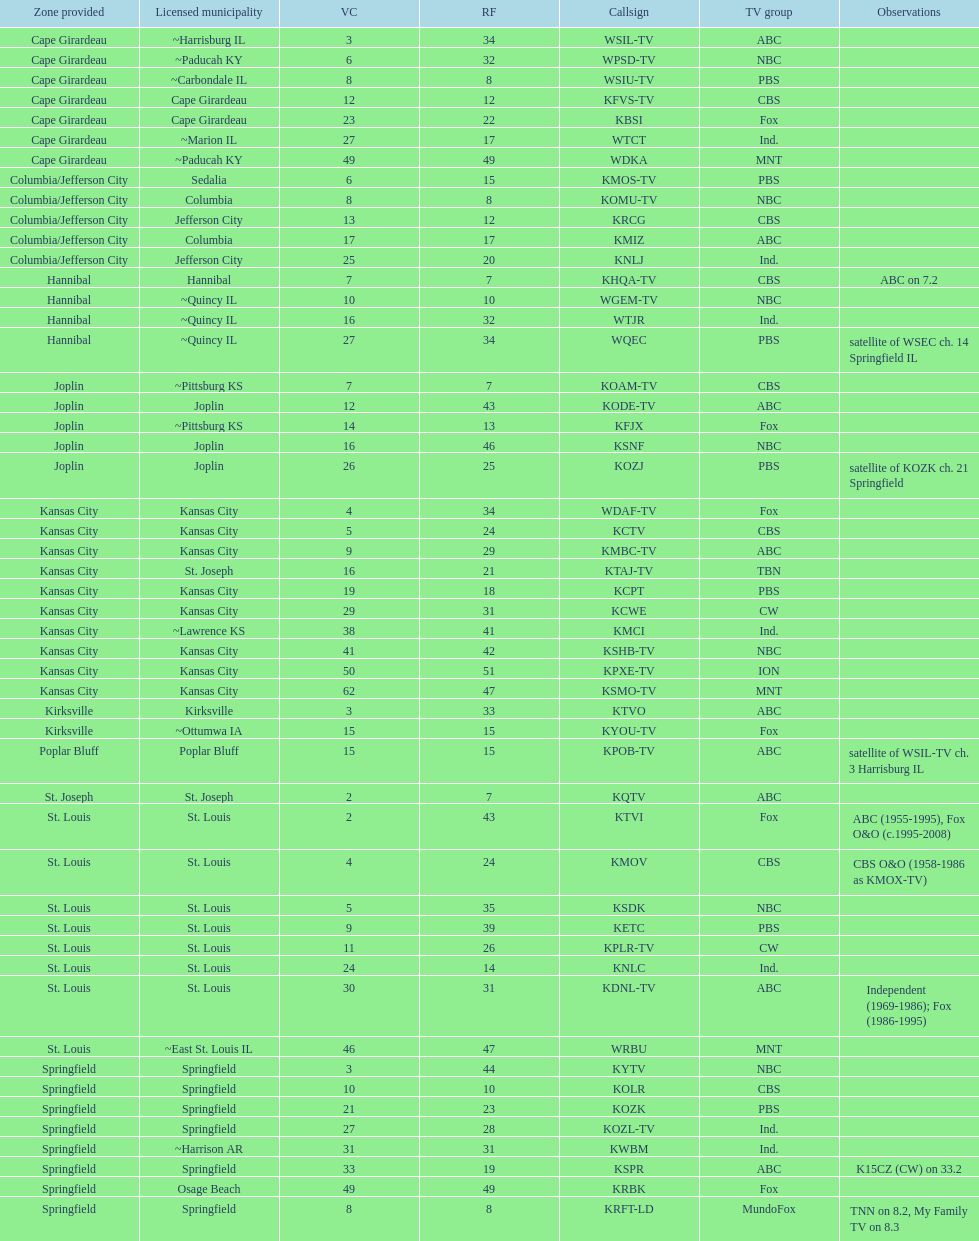How many areas have at least 5 stations? 6. 